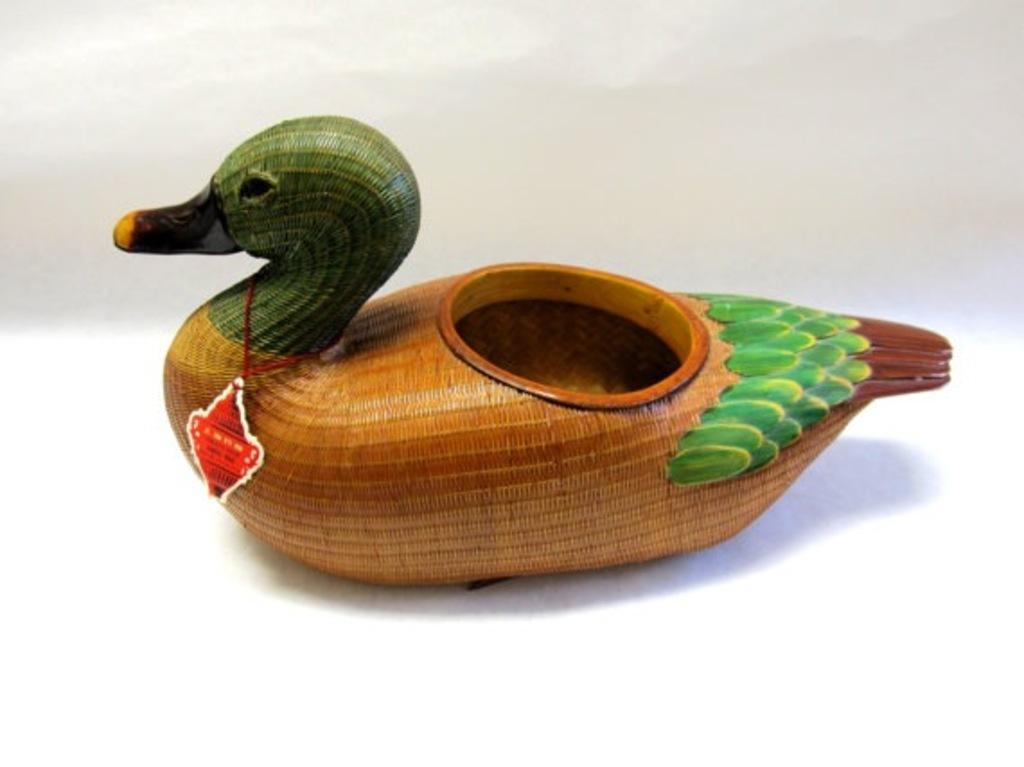What is the main subject in the center of the image? There is a duck toy in the center of the image. What type of bean is present in the image? There is no bean present in the image; the main subject is a duck toy. What is the condition of the toe in the image? There is no toe present in the image; the main subject is a duck toy. 